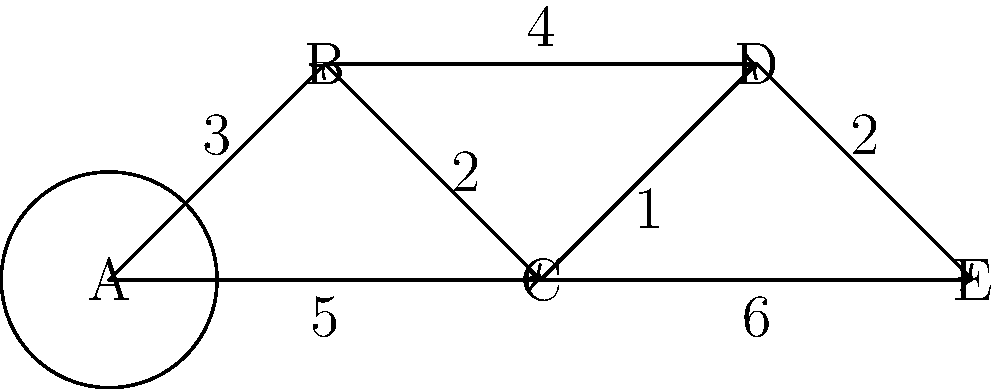In a network of refugee support centers, each node represents a center, and the edges represent direct connections between centers with their associated travel times (in hours). What is the shortest path from center A to center E, and what is the total travel time for this path? To find the shortest path from A to E, we need to consider all possible paths and their total travel times. Let's break it down step by step:

1. Possible paths from A to E:
   a) A → B → D → E
   b) A → C → D → E
   c) A → C → E

2. Calculate the travel time for each path:
   a) A → B → D → E: 3 + 4 + 2 = 9 hours
   b) A → C → D → E: 5 + 1 + 2 = 8 hours
   c) A → C → E: 5 + 6 = 11 hours

3. Compare the total travel times:
   Path (b) has the shortest total travel time of 8 hours.

4. Identify the shortest path:
   The shortest path is A → C → D → E.

Therefore, the shortest path from center A to center E is A → C → D → E, with a total travel time of 8 hours.
Answer: A → C → D → E, 8 hours 